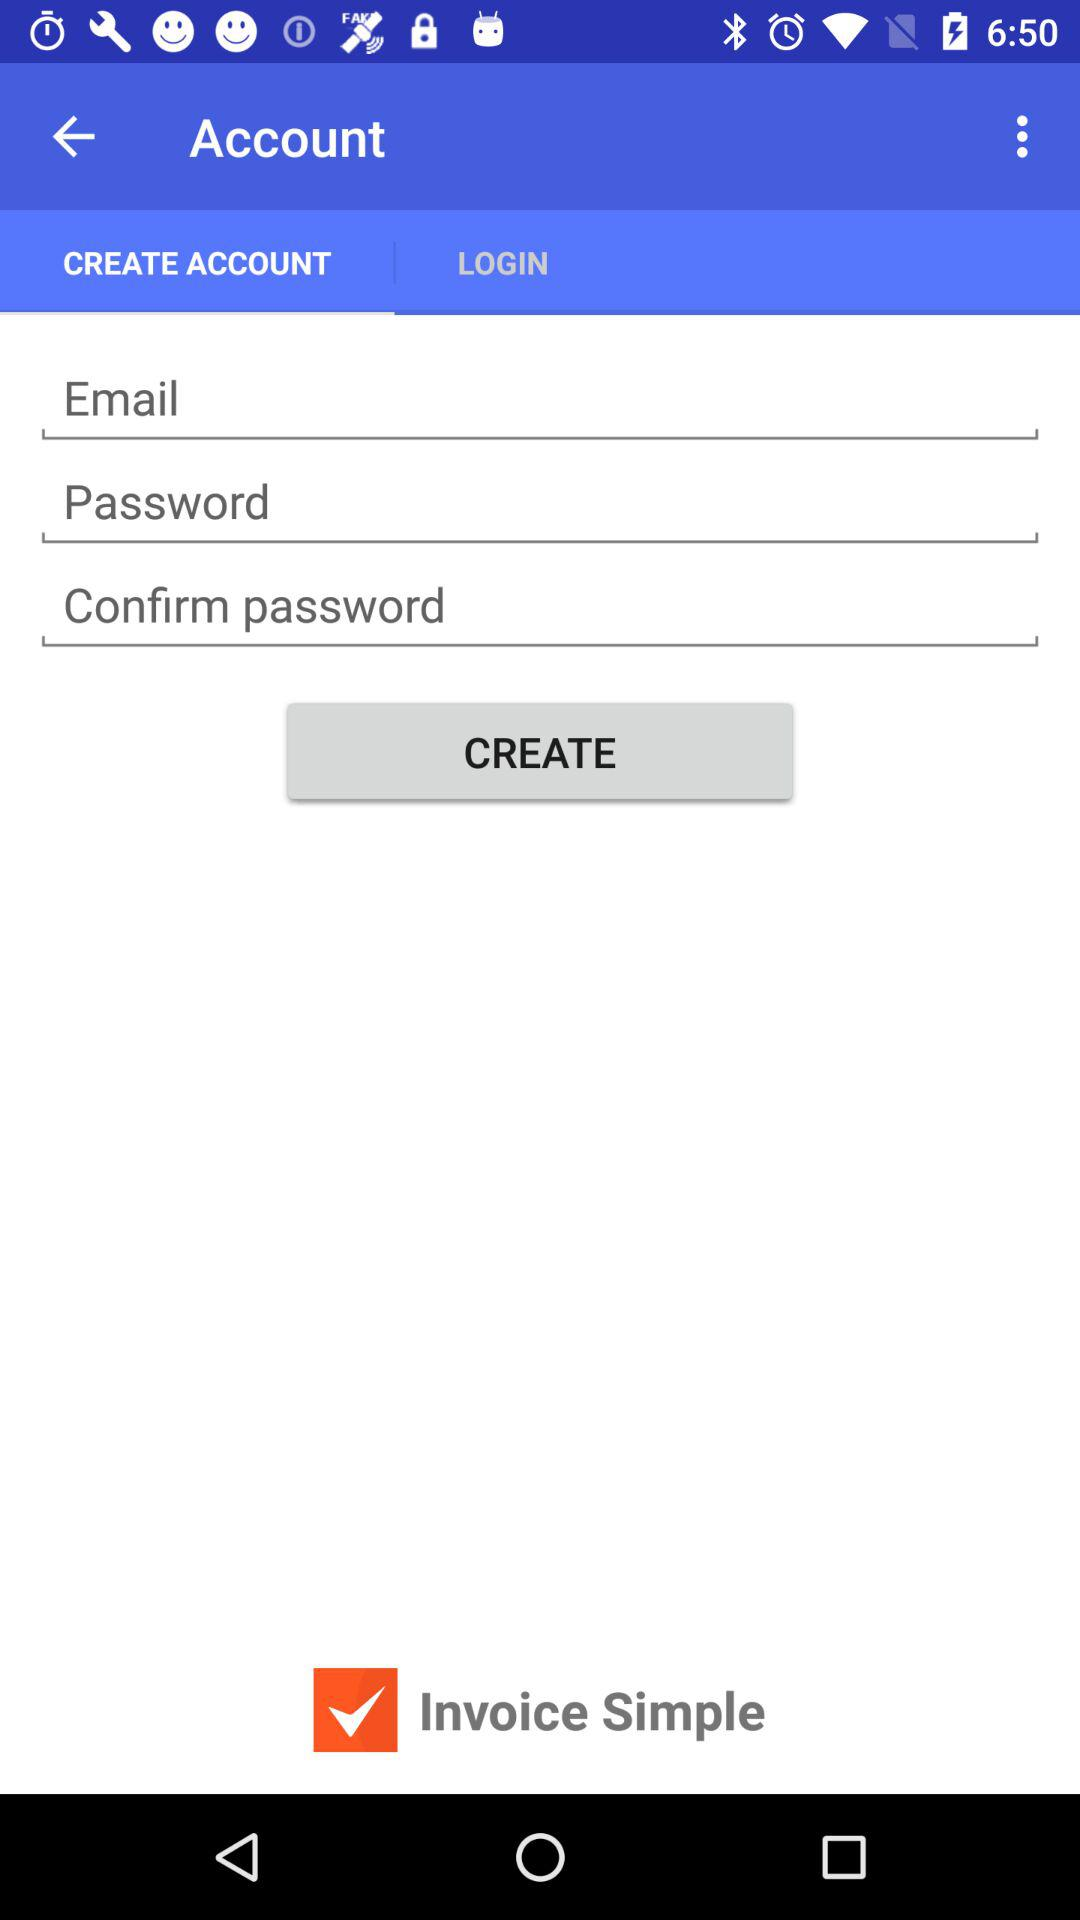Which tab is selected? The tab is Create Account. 